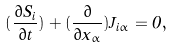Convert formula to latex. <formula><loc_0><loc_0><loc_500><loc_500>( \frac { \partial S _ { i } } { \partial t } ) + ( \frac { \partial } { \partial x _ { \alpha } } ) J _ { i \alpha } = 0 ,</formula> 